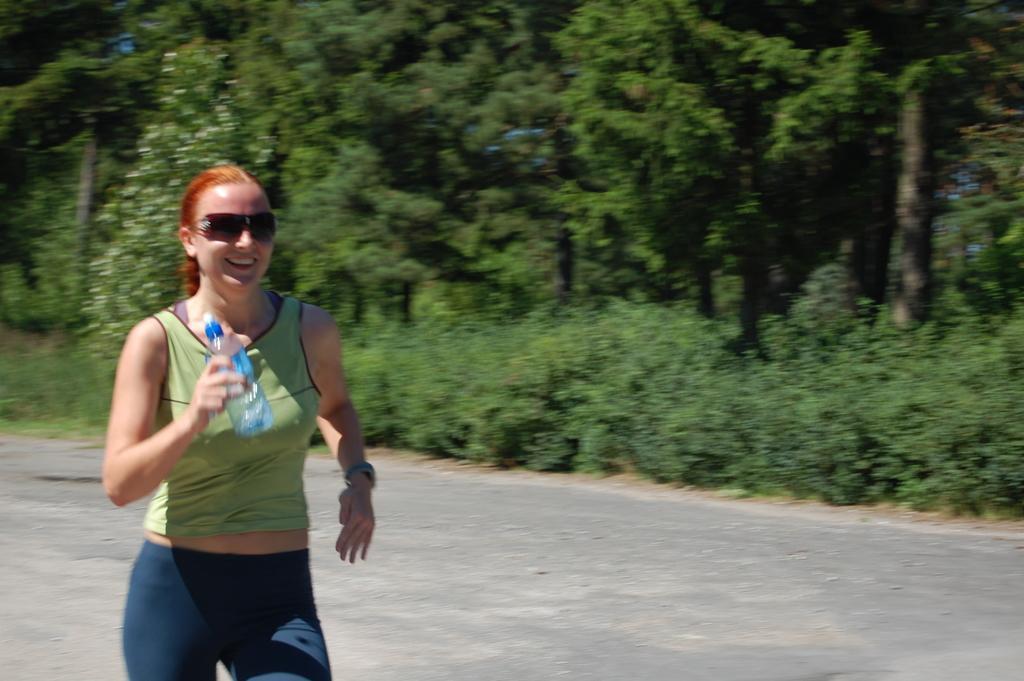Please provide a concise description of this image. In the image we can see there is a woman who is standing and she is holding water bottle in her hand and her back there are lot of trees. 